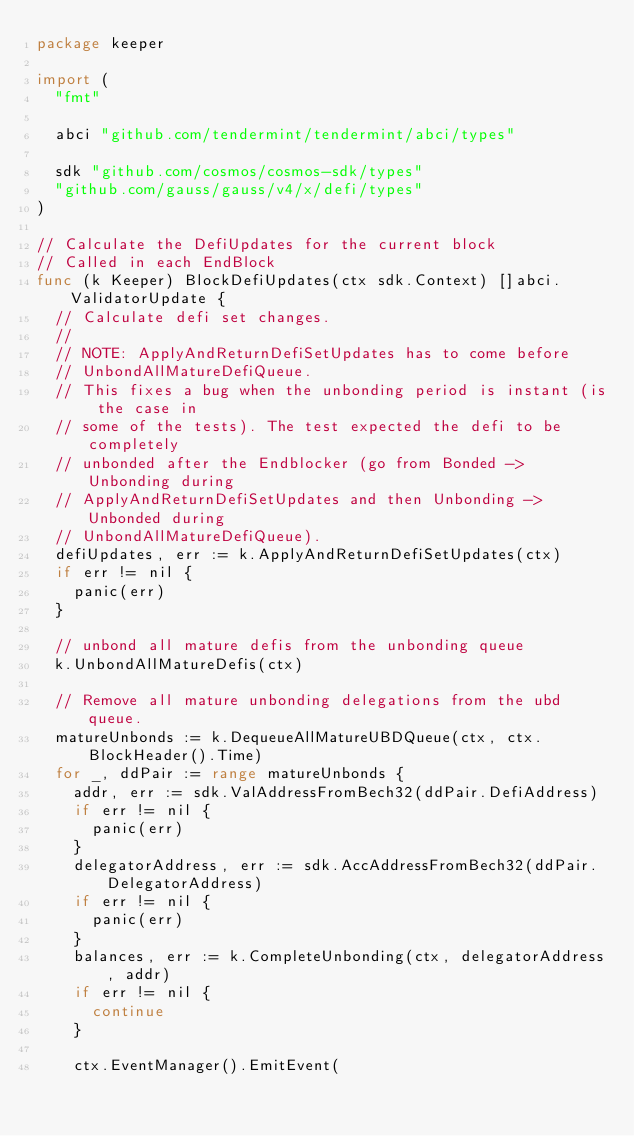Convert code to text. <code><loc_0><loc_0><loc_500><loc_500><_Go_>package keeper

import (
	"fmt"

	abci "github.com/tendermint/tendermint/abci/types"

	sdk "github.com/cosmos/cosmos-sdk/types"
	"github.com/gauss/gauss/v4/x/defi/types"
)

// Calculate the DefiUpdates for the current block
// Called in each EndBlock
func (k Keeper) BlockDefiUpdates(ctx sdk.Context) []abci.ValidatorUpdate {
	// Calculate defi set changes.
	//
	// NOTE: ApplyAndReturnDefiSetUpdates has to come before
	// UnbondAllMatureDefiQueue.
	// This fixes a bug when the unbonding period is instant (is the case in
	// some of the tests). The test expected the defi to be completely
	// unbonded after the Endblocker (go from Bonded -> Unbonding during
	// ApplyAndReturnDefiSetUpdates and then Unbonding -> Unbonded during
	// UnbondAllMatureDefiQueue).
	defiUpdates, err := k.ApplyAndReturnDefiSetUpdates(ctx)
	if err != nil {
		panic(err)
	}

	// unbond all mature defis from the unbonding queue
	k.UnbondAllMatureDefis(ctx)

	// Remove all mature unbonding delegations from the ubd queue.
	matureUnbonds := k.DequeueAllMatureUBDQueue(ctx, ctx.BlockHeader().Time)
	for _, ddPair := range matureUnbonds {
		addr, err := sdk.ValAddressFromBech32(ddPair.DefiAddress)
		if err != nil {
			panic(err)
		}
		delegatorAddress, err := sdk.AccAddressFromBech32(ddPair.DelegatorAddress)
		if err != nil {
			panic(err)
		}
		balances, err := k.CompleteUnbonding(ctx, delegatorAddress, addr)
		if err != nil {
			continue
		}

		ctx.EventManager().EmitEvent(</code> 